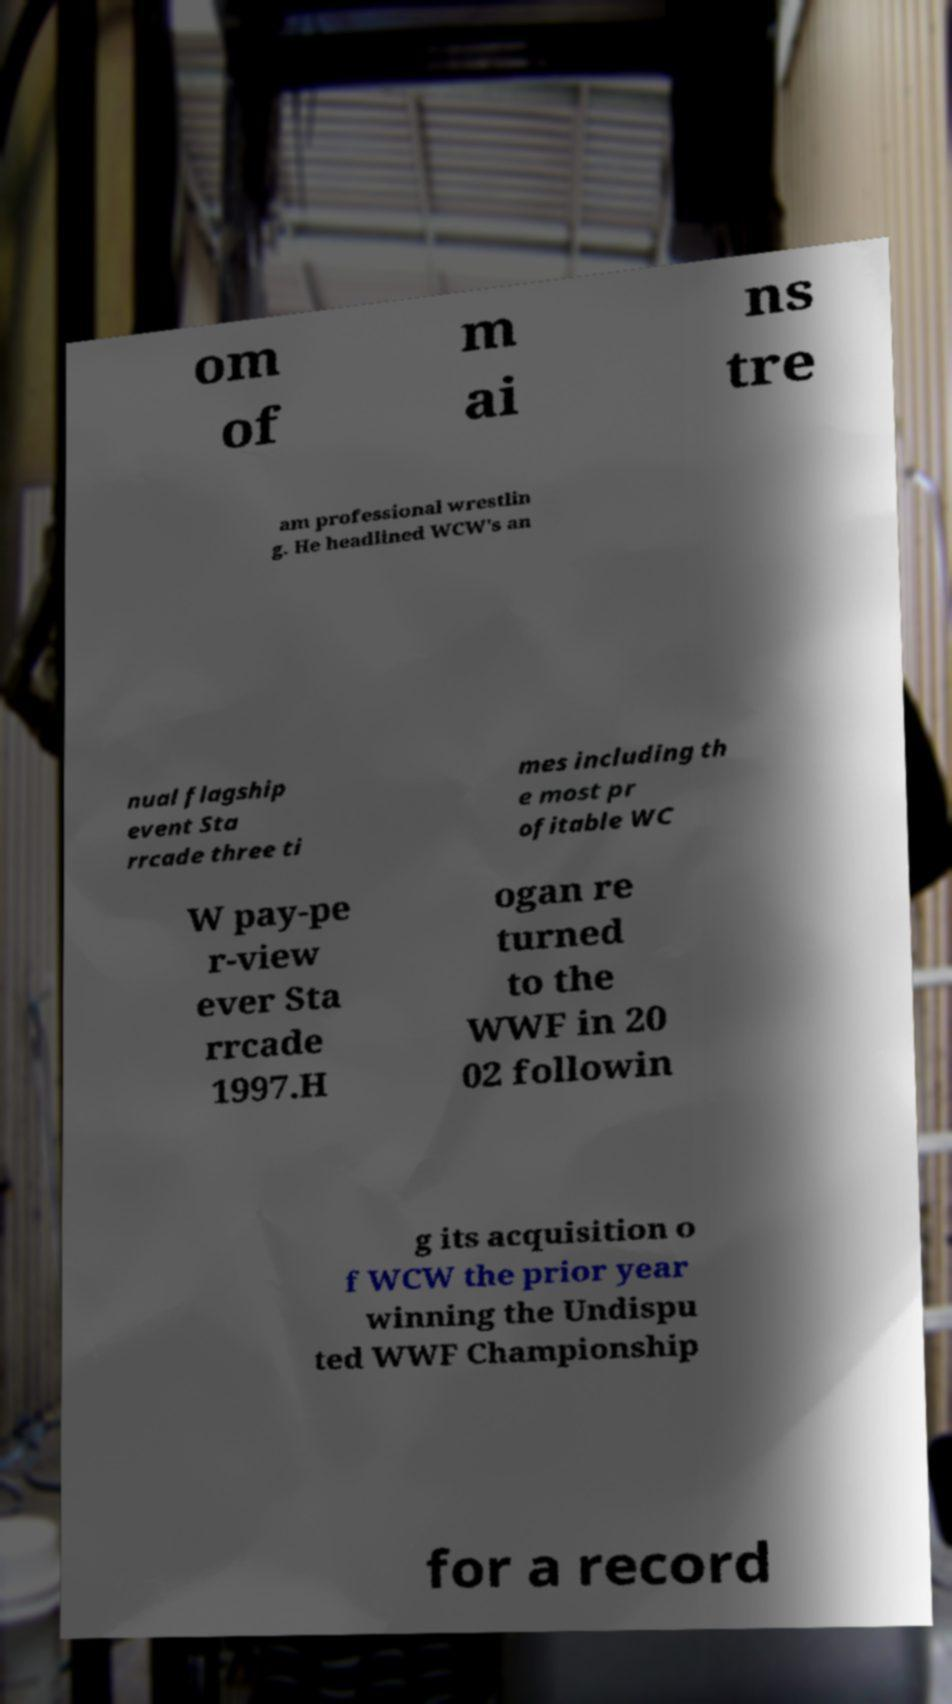I need the written content from this picture converted into text. Can you do that? om of m ai ns tre am professional wrestlin g. He headlined WCW's an nual flagship event Sta rrcade three ti mes including th e most pr ofitable WC W pay-pe r-view ever Sta rrcade 1997.H ogan re turned to the WWF in 20 02 followin g its acquisition o f WCW the prior year winning the Undispu ted WWF Championship for a record 